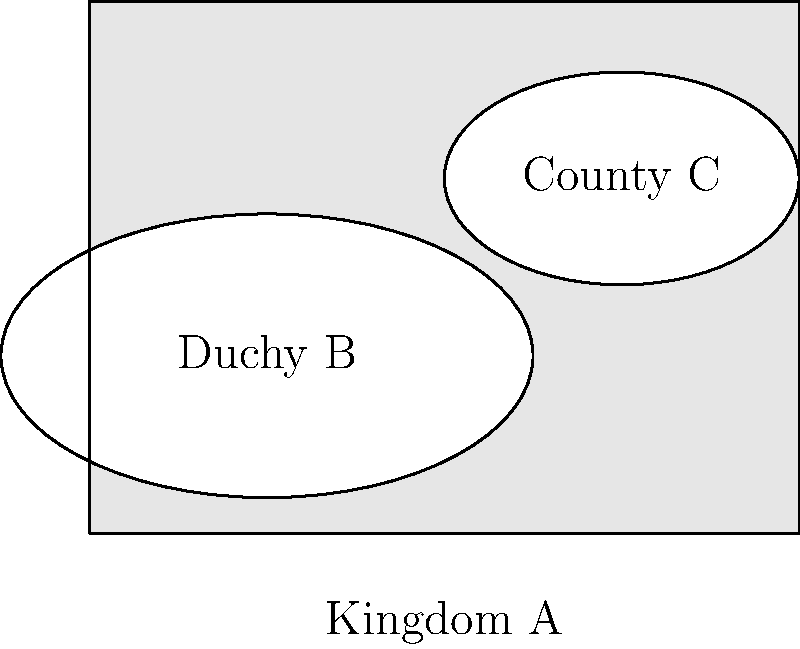In the medieval map above, Kingdom A is represented by the rectangular area. Duchy B and County C, two autonomous regions within Kingdom A, are represented by the overlapping ellipses. The dimensions of Kingdom A are 4 units by 3 units. The area of Duchy B is $\frac{3\pi}{2}$ square units, and the area of County C is $\frac{3\pi}{5}$ square units. The overlapping area between Duchy B and County C is $\frac{\pi}{4}$ square units. Calculate the percentage of Kingdom A's territory that remains under its direct control (i.e., not part of either Duchy B or County C). Round your answer to the nearest whole percent. Let's approach this step-by-step:

1) First, calculate the total area of Kingdom A:
   Area of Kingdom A = $4 \times 3 = 12$ square units

2) Now, we need to find the total area occupied by Duchy B and County C. We can't simply add their areas because they overlap. We need to use the principle of inclusion-exclusion:
   Total area of Duchy B and County C = Area of B + Area of C - Area of overlap
   $= \frac{3\pi}{2} + \frac{3\pi}{5} - \frac{\pi}{4}$
   $= \frac{15\pi}{10} + \frac{6\pi}{10} - \frac{5\pi}{20}$
   $= \frac{21\pi}{10} - \frac{5\pi}{20}$
   $= \frac{42\pi}{20} - \frac{5\pi}{20}$
   $= \frac{37\pi}{20}$

3) The area under Kingdom A's direct control is the total area minus the area occupied by Duchy B and County C:
   Area under direct control = $12 - \frac{37\pi}{20}$

4) To calculate the percentage, we divide this by the total area and multiply by 100:
   Percentage = $\frac{12 - \frac{37\pi}{20}}{12} \times 100$
              $= (1 - \frac{37\pi}{240}) \times 100$
              $\approx 51.69\%$

5) Rounding to the nearest whole percent gives us 52%.
Answer: 52% 